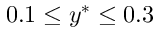Convert formula to latex. <formula><loc_0><loc_0><loc_500><loc_500>0 . 1 \leq y ^ { * } \leq 0 . 3</formula> 